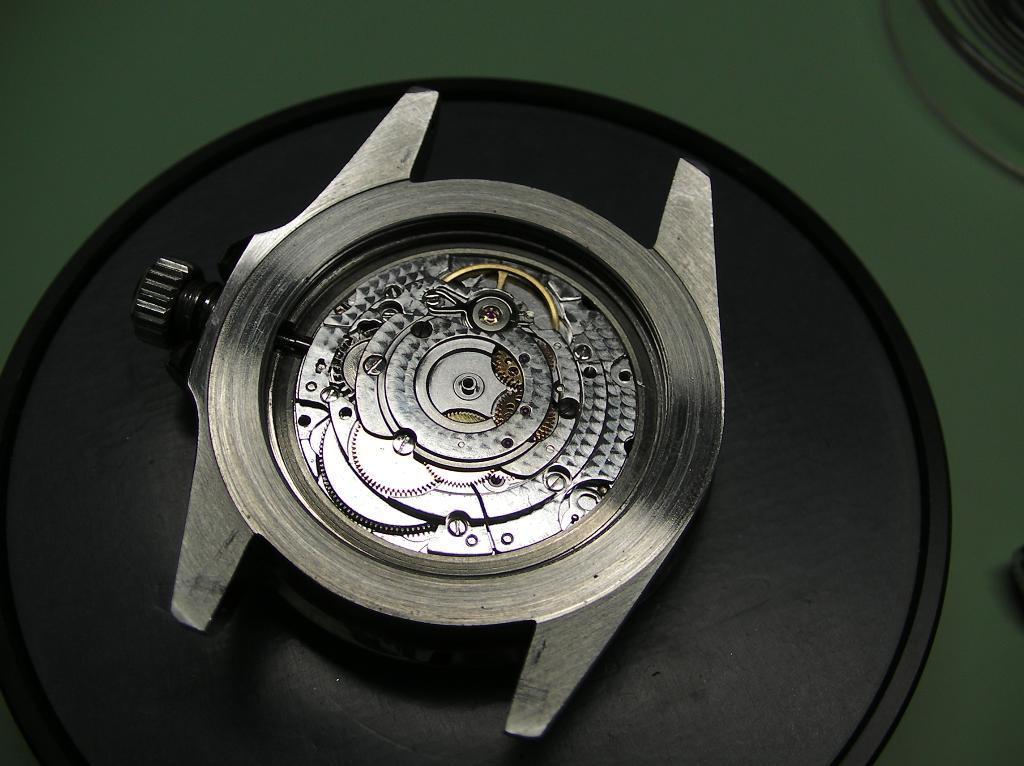Could you give a brief overview of what you see in this image? In this image there is dial of a watch on an object. 